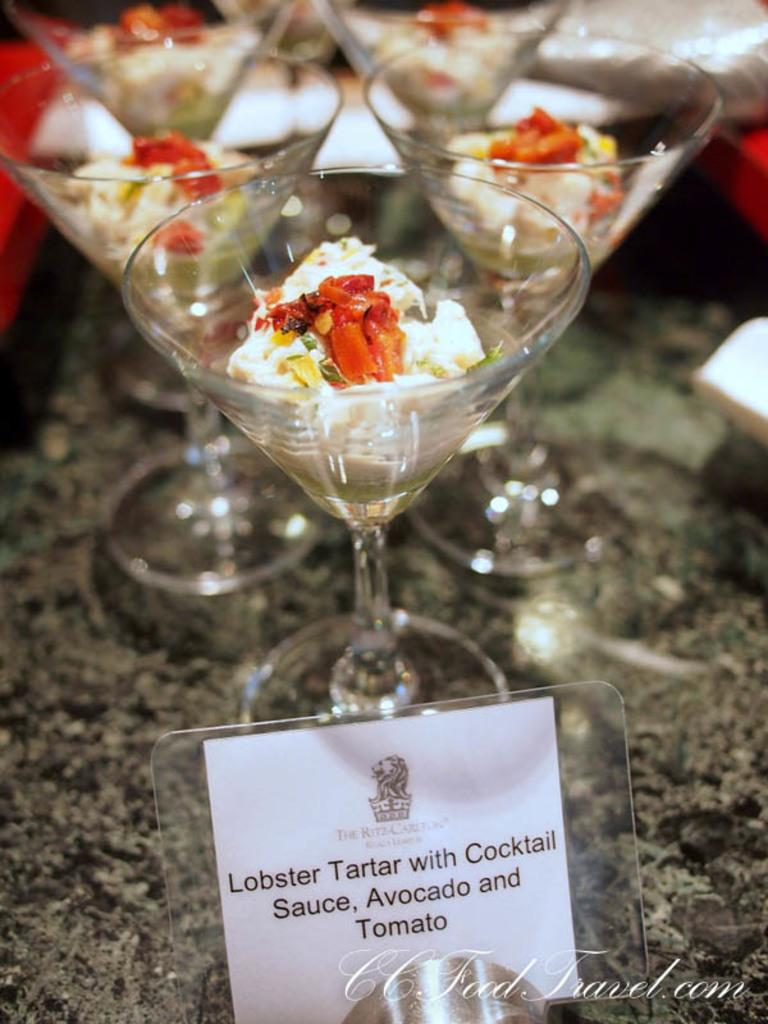What objects are arranged in a group in the image? There is a group of glasses in the image. What is inside the glasses? There is food in the glasses. What is written or drawn on the paper at the bottom of the image? The provided facts do not mention any specific text or drawing on the paper. Can you describe the arrangement of the glasses and food in the image? The glasses are arranged in a group, and each glass contains food. Where is the girl sleeping in the image? There is no girl or bedroom present in the image. What day of the week is it in the image? The provided facts do not mention any specific day of the week or time of day. 